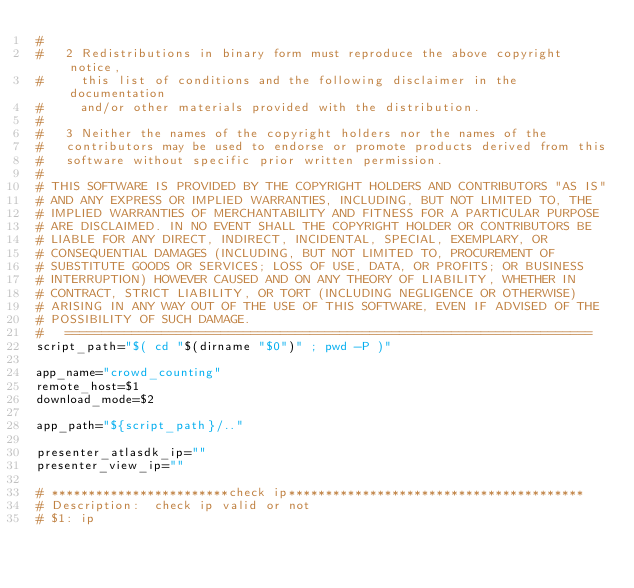Convert code to text. <code><loc_0><loc_0><loc_500><loc_500><_Bash_>#
#   2 Redistributions in binary form must reproduce the above copyright notice,
#     this list of conditions and the following disclaimer in the documentation
#     and/or other materials provided with the distribution.
#
#   3 Neither the names of the copyright holders nor the names of the
#   contributors may be used to endorse or promote products derived from this
#   software without specific prior written permission.
#
# THIS SOFTWARE IS PROVIDED BY THE COPYRIGHT HOLDERS AND CONTRIBUTORS "AS IS"
# AND ANY EXPRESS OR IMPLIED WARRANTIES, INCLUDING, BUT NOT LIMITED TO, THE
# IMPLIED WARRANTIES OF MERCHANTABILITY AND FITNESS FOR A PARTICULAR PURPOSE
# ARE DISCLAIMED. IN NO EVENT SHALL THE COPYRIGHT HOLDER OR CONTRIBUTORS BE
# LIABLE FOR ANY DIRECT, INDIRECT, INCIDENTAL, SPECIAL, EXEMPLARY, OR
# CONSEQUENTIAL DAMAGES (INCLUDING, BUT NOT LIMITED TO, PROCUREMENT OF
# SUBSTITUTE GOODS OR SERVICES; LOSS OF USE, DATA, OR PROFITS; OR BUSINESS
# INTERRUPTION) HOWEVER CAUSED AND ON ANY THEORY OF LIABILITY, WHETHER IN
# CONTRACT, STRICT LIABILITY, OR TORT (INCLUDING NEGLIGENCE OR OTHERWISE)
# ARISING IN ANY WAY OUT OF THE USE OF THIS SOFTWARE, EVEN IF ADVISED OF THE
# POSSIBILITY OF SUCH DAMAGE.
#   =======================================================================
script_path="$( cd "$(dirname "$0")" ; pwd -P )"

app_name="crowd_counting"
remote_host=$1
download_mode=$2

app_path="${script_path}/.."

presenter_atlasdk_ip=""
presenter_view_ip=""

# ************************check ip****************************************
# Description:  check ip valid or not
# $1: ip</code> 